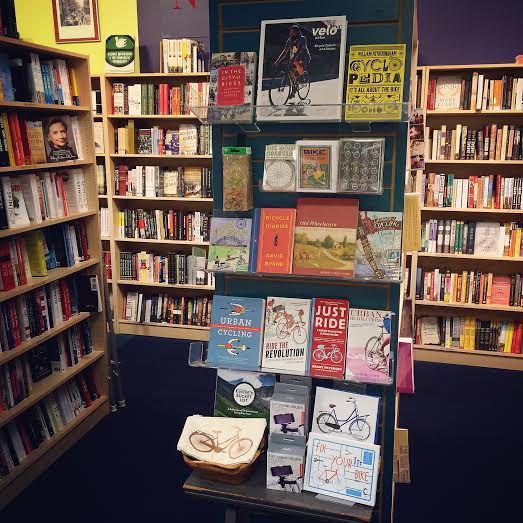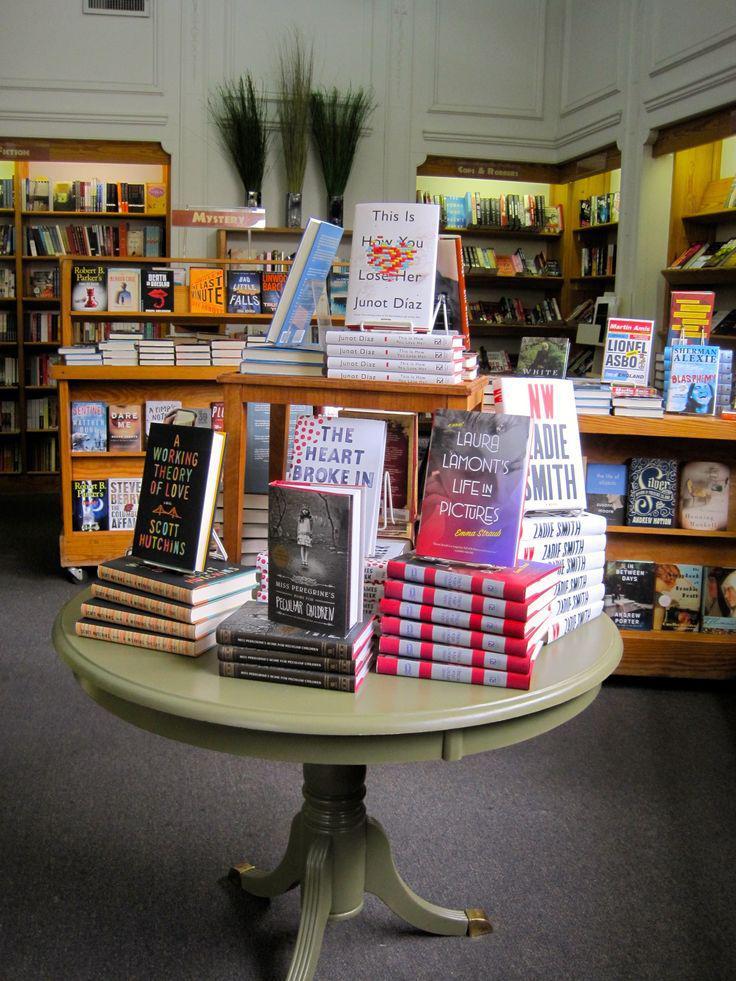The first image is the image on the left, the second image is the image on the right. Analyze the images presented: Is the assertion "In the right image, a woman with a large handbag is framed by an opening between bookshelves." valid? Answer yes or no. No. The first image is the image on the left, the second image is the image on the right. Evaluate the accuracy of this statement regarding the images: "At least two people are shopping for books.". Is it true? Answer yes or no. No. 